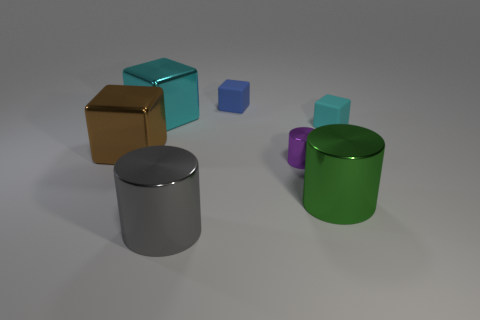Subtract 1 cubes. How many cubes are left? 3 Add 1 brown objects. How many objects exist? 8 Subtract all cylinders. How many objects are left? 4 Add 5 brown blocks. How many brown blocks are left? 6 Add 7 big blue things. How many big blue things exist? 7 Subtract 0 red spheres. How many objects are left? 7 Subtract all brown matte cubes. Subtract all blocks. How many objects are left? 3 